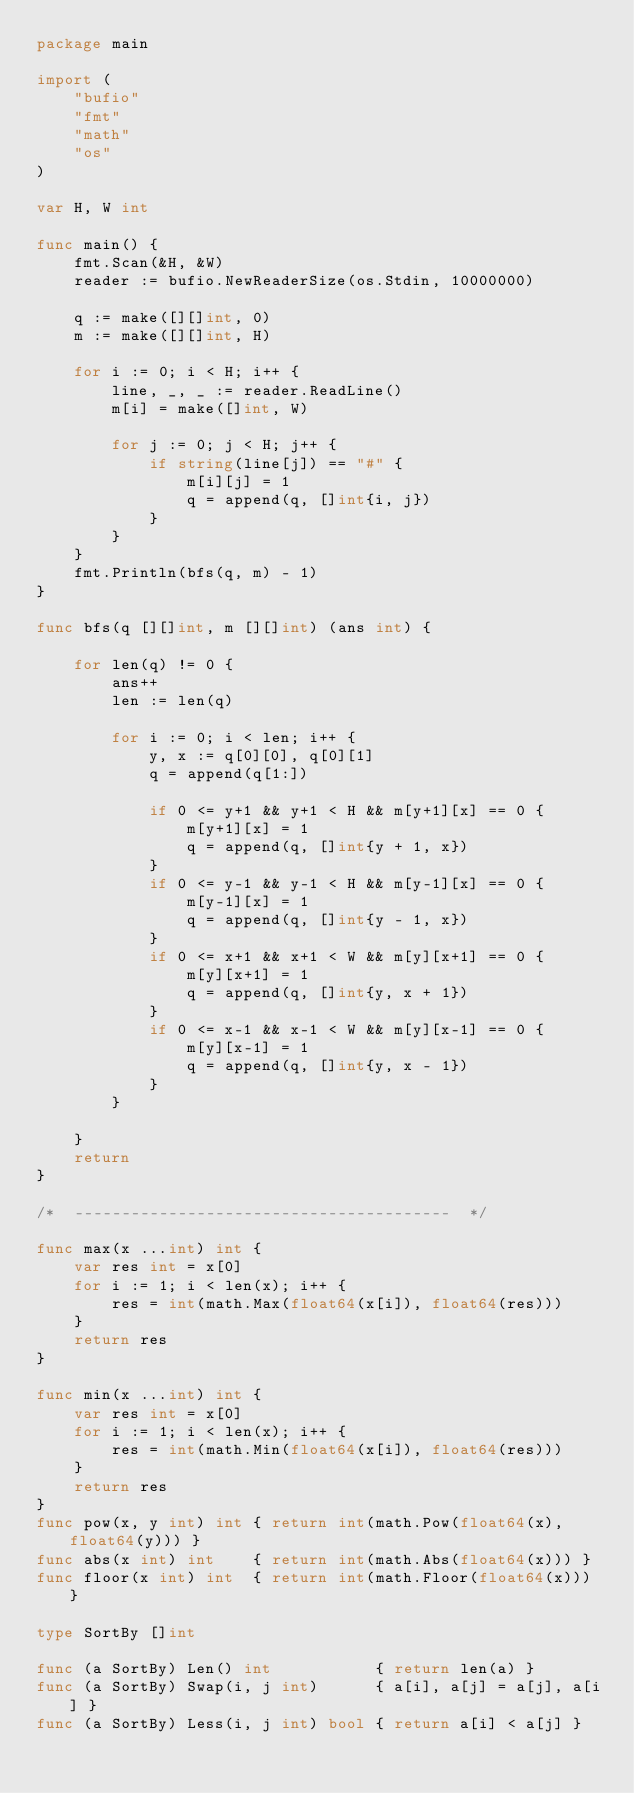Convert code to text. <code><loc_0><loc_0><loc_500><loc_500><_Go_>package main

import (
	"bufio"
	"fmt"
	"math"
	"os"
)

var H, W int

func main() {
	fmt.Scan(&H, &W)
	reader := bufio.NewReaderSize(os.Stdin, 10000000)

	q := make([][]int, 0)
	m := make([][]int, H)

	for i := 0; i < H; i++ {
		line, _, _ := reader.ReadLine()
		m[i] = make([]int, W)

		for j := 0; j < H; j++ {
			if string(line[j]) == "#" {
				m[i][j] = 1
				q = append(q, []int{i, j})
			}
		}
	}
	fmt.Println(bfs(q, m) - 1)
}

func bfs(q [][]int, m [][]int) (ans int) {

	for len(q) != 0 {
		ans++
		len := len(q)

		for i := 0; i < len; i++ {
			y, x := q[0][0], q[0][1]
			q = append(q[1:])

			if 0 <= y+1 && y+1 < H && m[y+1][x] == 0 {
				m[y+1][x] = 1
				q = append(q, []int{y + 1, x})
			}
			if 0 <= y-1 && y-1 < H && m[y-1][x] == 0 {
				m[y-1][x] = 1
				q = append(q, []int{y - 1, x})
			}
			if 0 <= x+1 && x+1 < W && m[y][x+1] == 0 {
				m[y][x+1] = 1
				q = append(q, []int{y, x + 1})
			}
			if 0 <= x-1 && x-1 < W && m[y][x-1] == 0 {
				m[y][x-1] = 1
				q = append(q, []int{y, x - 1})
			}
		}

	}
	return
}

/*  ----------------------------------------  */

func max(x ...int) int {
	var res int = x[0]
	for i := 1; i < len(x); i++ {
		res = int(math.Max(float64(x[i]), float64(res)))
	}
	return res
}

func min(x ...int) int {
	var res int = x[0]
	for i := 1; i < len(x); i++ {
		res = int(math.Min(float64(x[i]), float64(res)))
	}
	return res
}
func pow(x, y int) int { return int(math.Pow(float64(x), float64(y))) }
func abs(x int) int    { return int(math.Abs(float64(x))) }
func floor(x int) int  { return int(math.Floor(float64(x))) }

type SortBy []int

func (a SortBy) Len() int           { return len(a) }
func (a SortBy) Swap(i, j int)      { a[i], a[j] = a[j], a[i] }
func (a SortBy) Less(i, j int) bool { return a[i] < a[j] }
</code> 